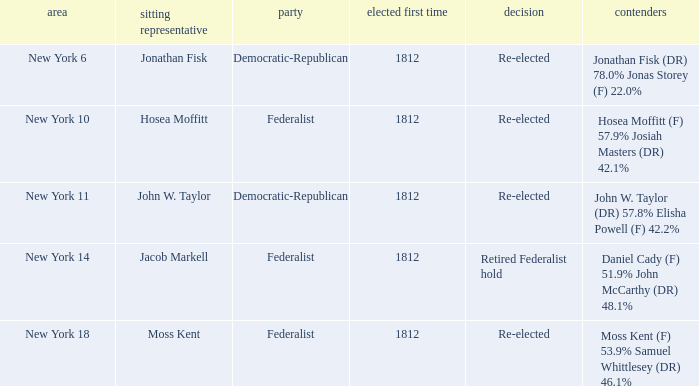Name the first elected for hosea moffitt (f) 57.9% josiah masters (dr) 42.1% 1812.0. 